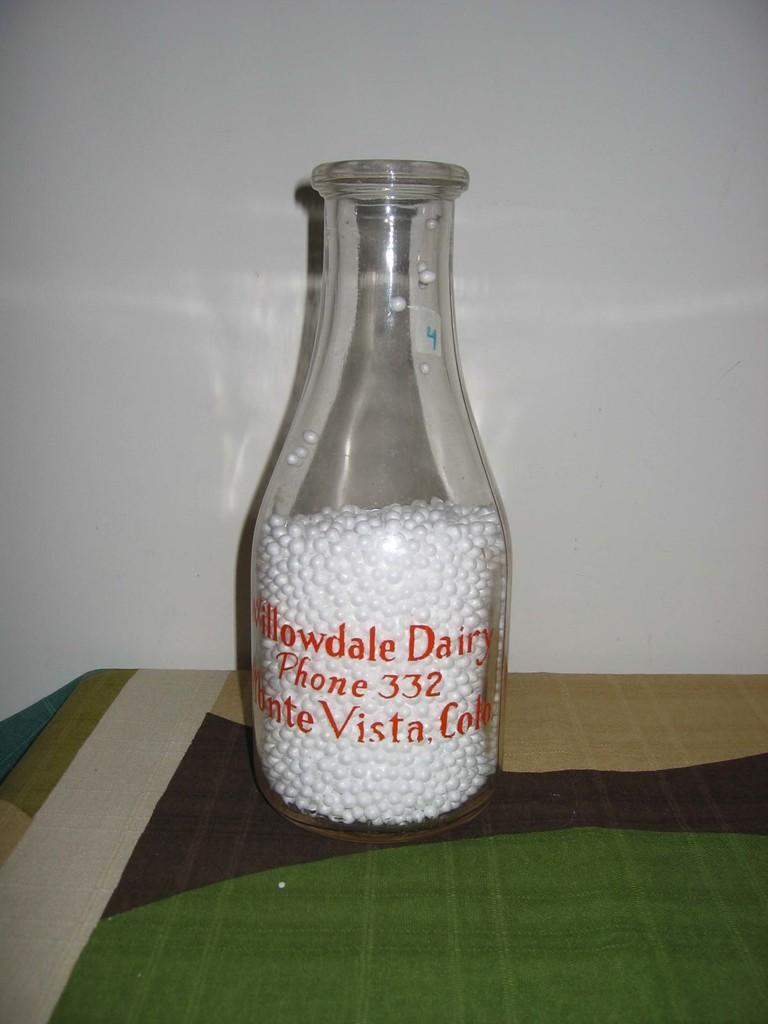<image>
Present a compact description of the photo's key features. A bottle for Willowdale Dairy is mostly filled with small Styrofoam white balls. 